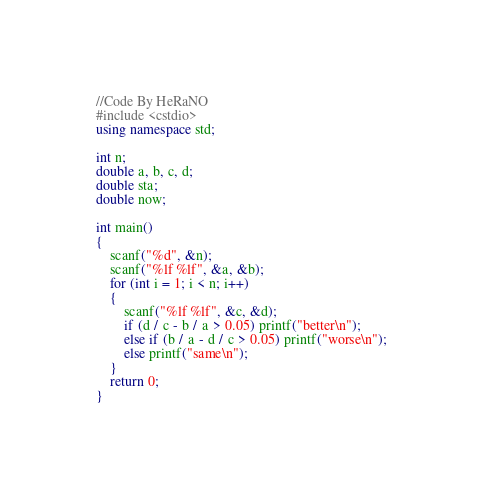Convert code to text. <code><loc_0><loc_0><loc_500><loc_500><_C++_>//Code By HeRaNO
#include <cstdio>
using namespace std;

int n;
double a, b, c, d;
double sta;
double now;

int main()
{
	scanf("%d", &n);
	scanf("%lf %lf", &a, &b);
	for (int i = 1; i < n; i++)
	{
		scanf("%lf %lf", &c, &d);
		if (d / c - b / a > 0.05) printf("better\n");
		else if (b / a - d / c > 0.05) printf("worse\n");
		else printf("same\n");
	}
	return 0;
}
</code> 